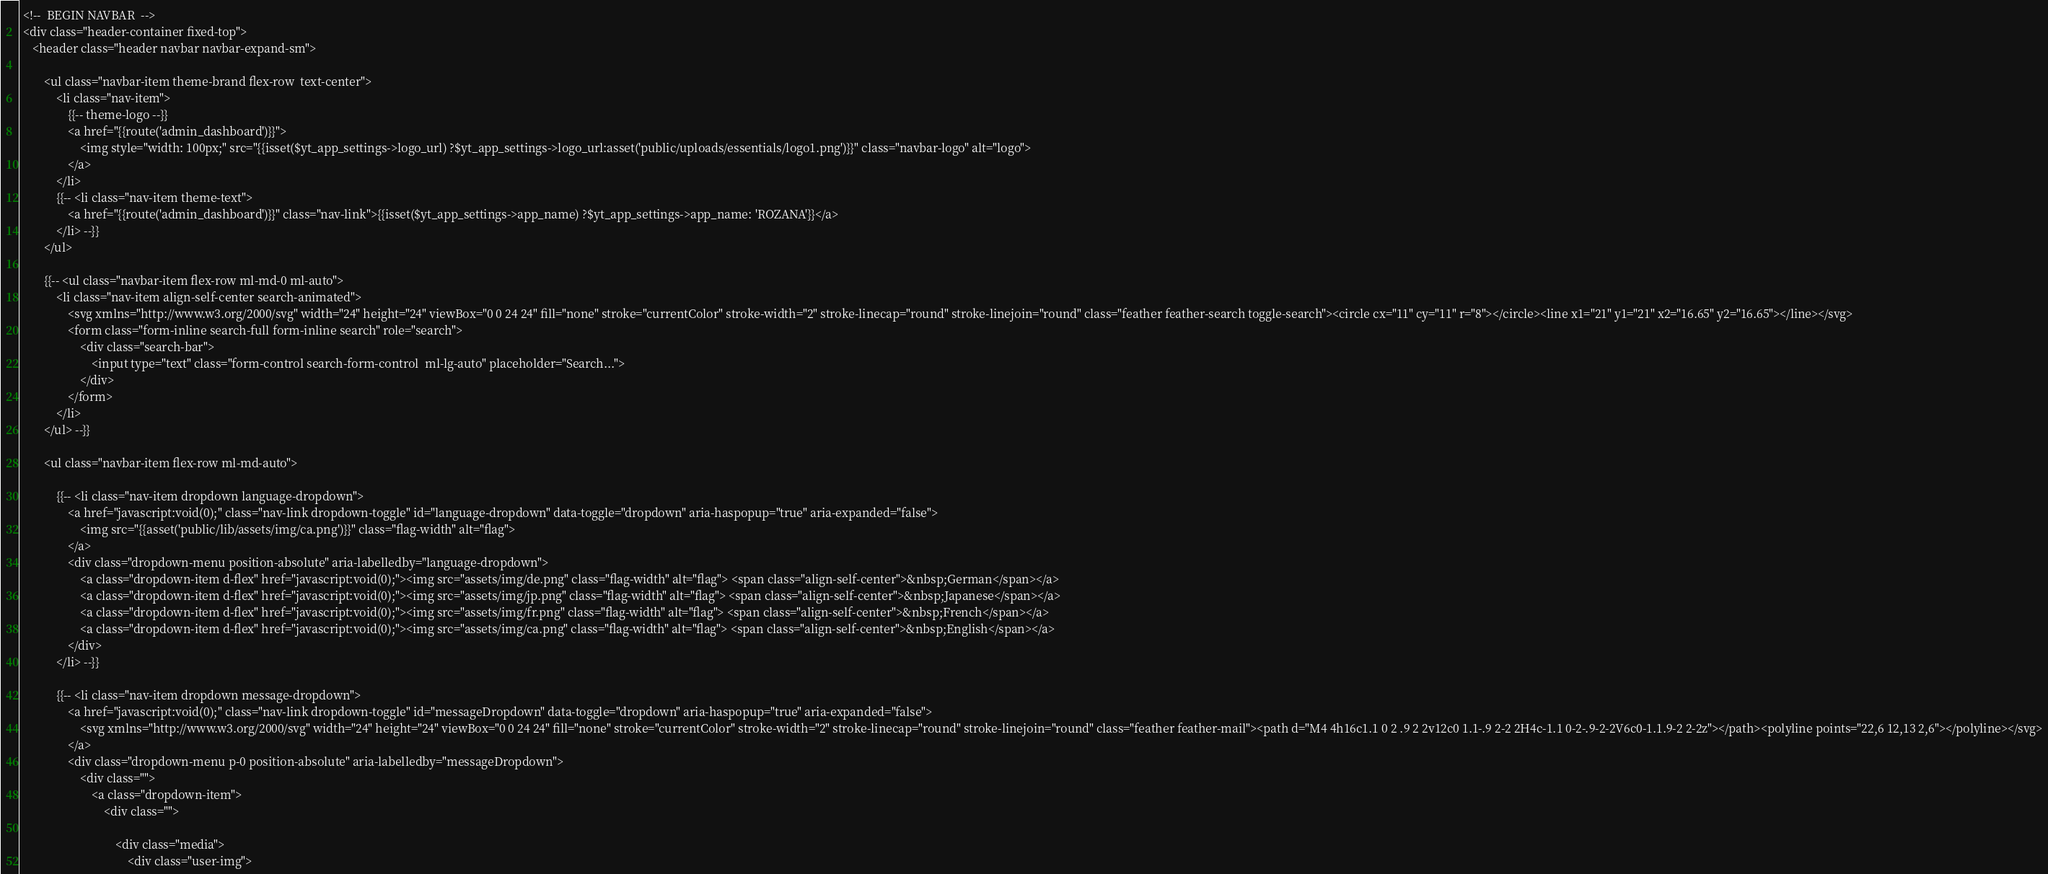Convert code to text. <code><loc_0><loc_0><loc_500><loc_500><_PHP_> <!--  BEGIN NAVBAR  -->
 <div class="header-container fixed-top">
    <header class="header navbar navbar-expand-sm">

        <ul class="navbar-item theme-brand flex-row  text-center">
            <li class="nav-item">
                {{-- theme-logo --}}
                <a href="{{route('admin_dashboard')}}">
                    <img style="width: 100px;" src="{{isset($yt_app_settings->logo_url) ?$yt_app_settings->logo_url:asset('public/uploads/essentials/logo1.png')}}" class="navbar-logo" alt="logo">
                </a>
            </li>
            {{-- <li class="nav-item theme-text">
                <a href="{{route('admin_dashboard')}}" class="nav-link">{{isset($yt_app_settings->app_name) ?$yt_app_settings->app_name: 'ROZANA'}}</a>
            </li> --}}
        </ul>

        {{-- <ul class="navbar-item flex-row ml-md-0 ml-auto">
            <li class="nav-item align-self-center search-animated">
                <svg xmlns="http://www.w3.org/2000/svg" width="24" height="24" viewBox="0 0 24 24" fill="none" stroke="currentColor" stroke-width="2" stroke-linecap="round" stroke-linejoin="round" class="feather feather-search toggle-search"><circle cx="11" cy="11" r="8"></circle><line x1="21" y1="21" x2="16.65" y2="16.65"></line></svg>
                <form class="form-inline search-full form-inline search" role="search">
                    <div class="search-bar">
                        <input type="text" class="form-control search-form-control  ml-lg-auto" placeholder="Search...">
                    </div>
                </form>
            </li>
        </ul> --}}

        <ul class="navbar-item flex-row ml-md-auto">

            {{-- <li class="nav-item dropdown language-dropdown">
                <a href="javascript:void(0);" class="nav-link dropdown-toggle" id="language-dropdown" data-toggle="dropdown" aria-haspopup="true" aria-expanded="false">
                    <img src="{{asset('public/lib/assets/img/ca.png')}}" class="flag-width" alt="flag">
                </a>
                <div class="dropdown-menu position-absolute" aria-labelledby="language-dropdown">
                    <a class="dropdown-item d-flex" href="javascript:void(0);"><img src="assets/img/de.png" class="flag-width" alt="flag"> <span class="align-self-center">&nbsp;German</span></a>
                    <a class="dropdown-item d-flex" href="javascript:void(0);"><img src="assets/img/jp.png" class="flag-width" alt="flag"> <span class="align-self-center">&nbsp;Japanese</span></a>
                    <a class="dropdown-item d-flex" href="javascript:void(0);"><img src="assets/img/fr.png" class="flag-width" alt="flag"> <span class="align-self-center">&nbsp;French</span></a>
                    <a class="dropdown-item d-flex" href="javascript:void(0);"><img src="assets/img/ca.png" class="flag-width" alt="flag"> <span class="align-self-center">&nbsp;English</span></a>
                </div>
            </li> --}}

            {{-- <li class="nav-item dropdown message-dropdown">
                <a href="javascript:void(0);" class="nav-link dropdown-toggle" id="messageDropdown" data-toggle="dropdown" aria-haspopup="true" aria-expanded="false">
                    <svg xmlns="http://www.w3.org/2000/svg" width="24" height="24" viewBox="0 0 24 24" fill="none" stroke="currentColor" stroke-width="2" stroke-linecap="round" stroke-linejoin="round" class="feather feather-mail"><path d="M4 4h16c1.1 0 2 .9 2 2v12c0 1.1-.9 2-2 2H4c-1.1 0-2-.9-2-2V6c0-1.1.9-2 2-2z"></path><polyline points="22,6 12,13 2,6"></polyline></svg>
                </a>
                <div class="dropdown-menu p-0 position-absolute" aria-labelledby="messageDropdown">
                    <div class="">
                        <a class="dropdown-item">
                            <div class="">

                                <div class="media">
                                    <div class="user-img"></code> 